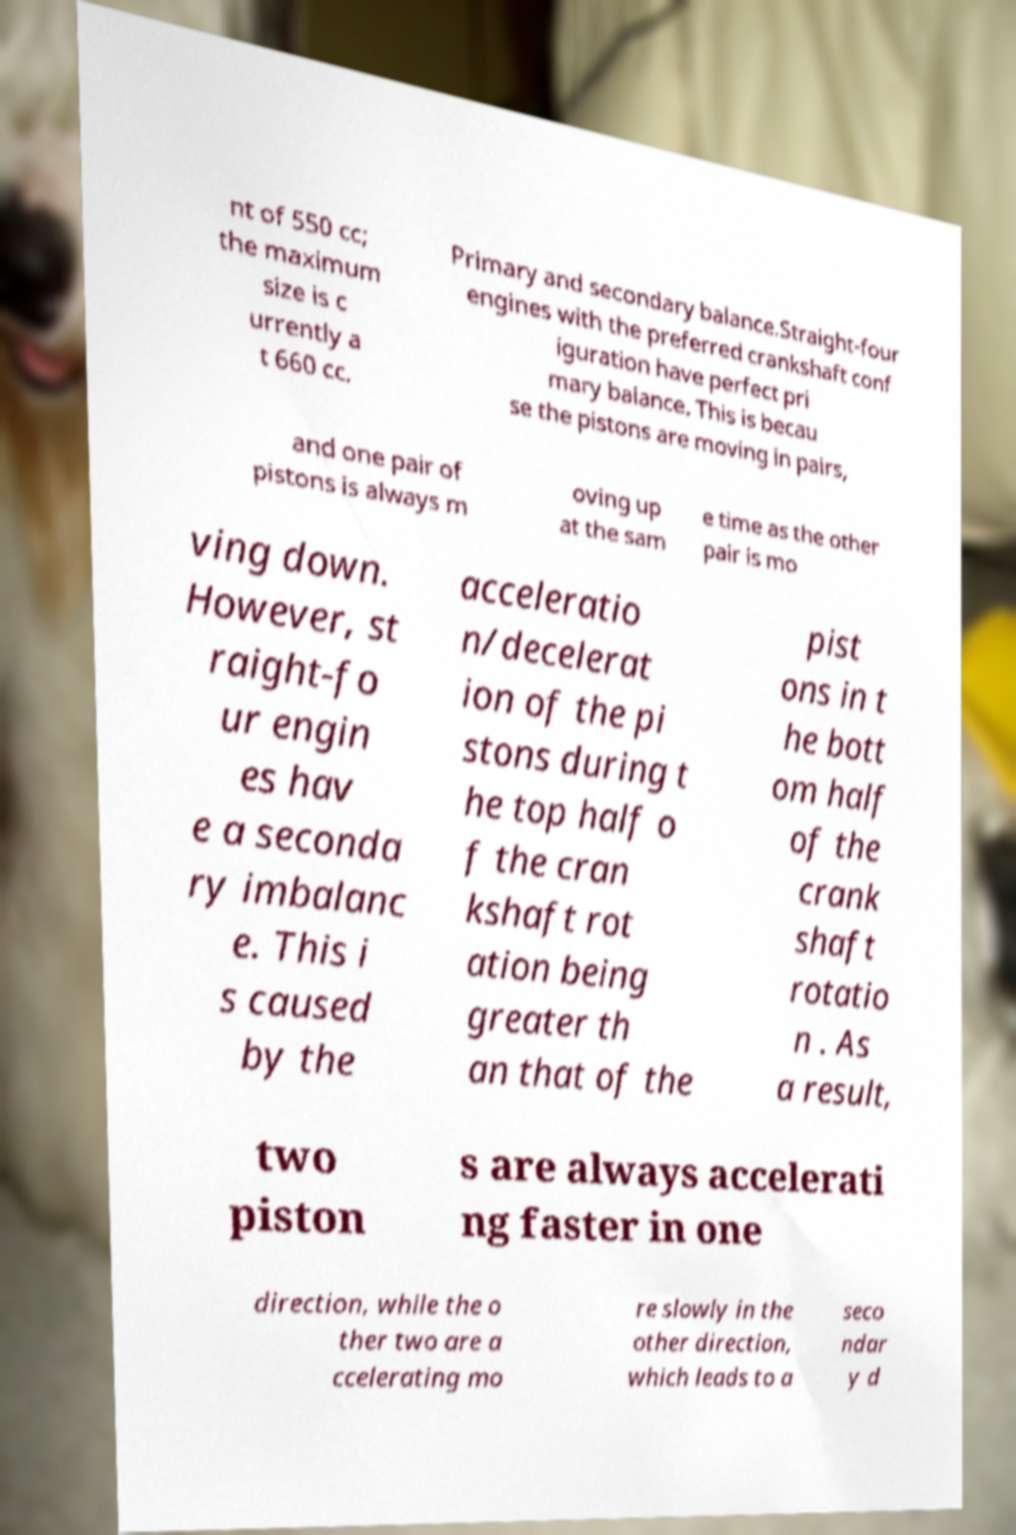I need the written content from this picture converted into text. Can you do that? nt of 550 cc; the maximum size is c urrently a t 660 cc. Primary and secondary balance.Straight-four engines with the preferred crankshaft conf iguration have perfect pri mary balance. This is becau se the pistons are moving in pairs, and one pair of pistons is always m oving up at the sam e time as the other pair is mo ving down. However, st raight-fo ur engin es hav e a seconda ry imbalanc e. This i s caused by the acceleratio n/decelerat ion of the pi stons during t he top half o f the cran kshaft rot ation being greater th an that of the pist ons in t he bott om half of the crank shaft rotatio n . As a result, two piston s are always accelerati ng faster in one direction, while the o ther two are a ccelerating mo re slowly in the other direction, which leads to a seco ndar y d 